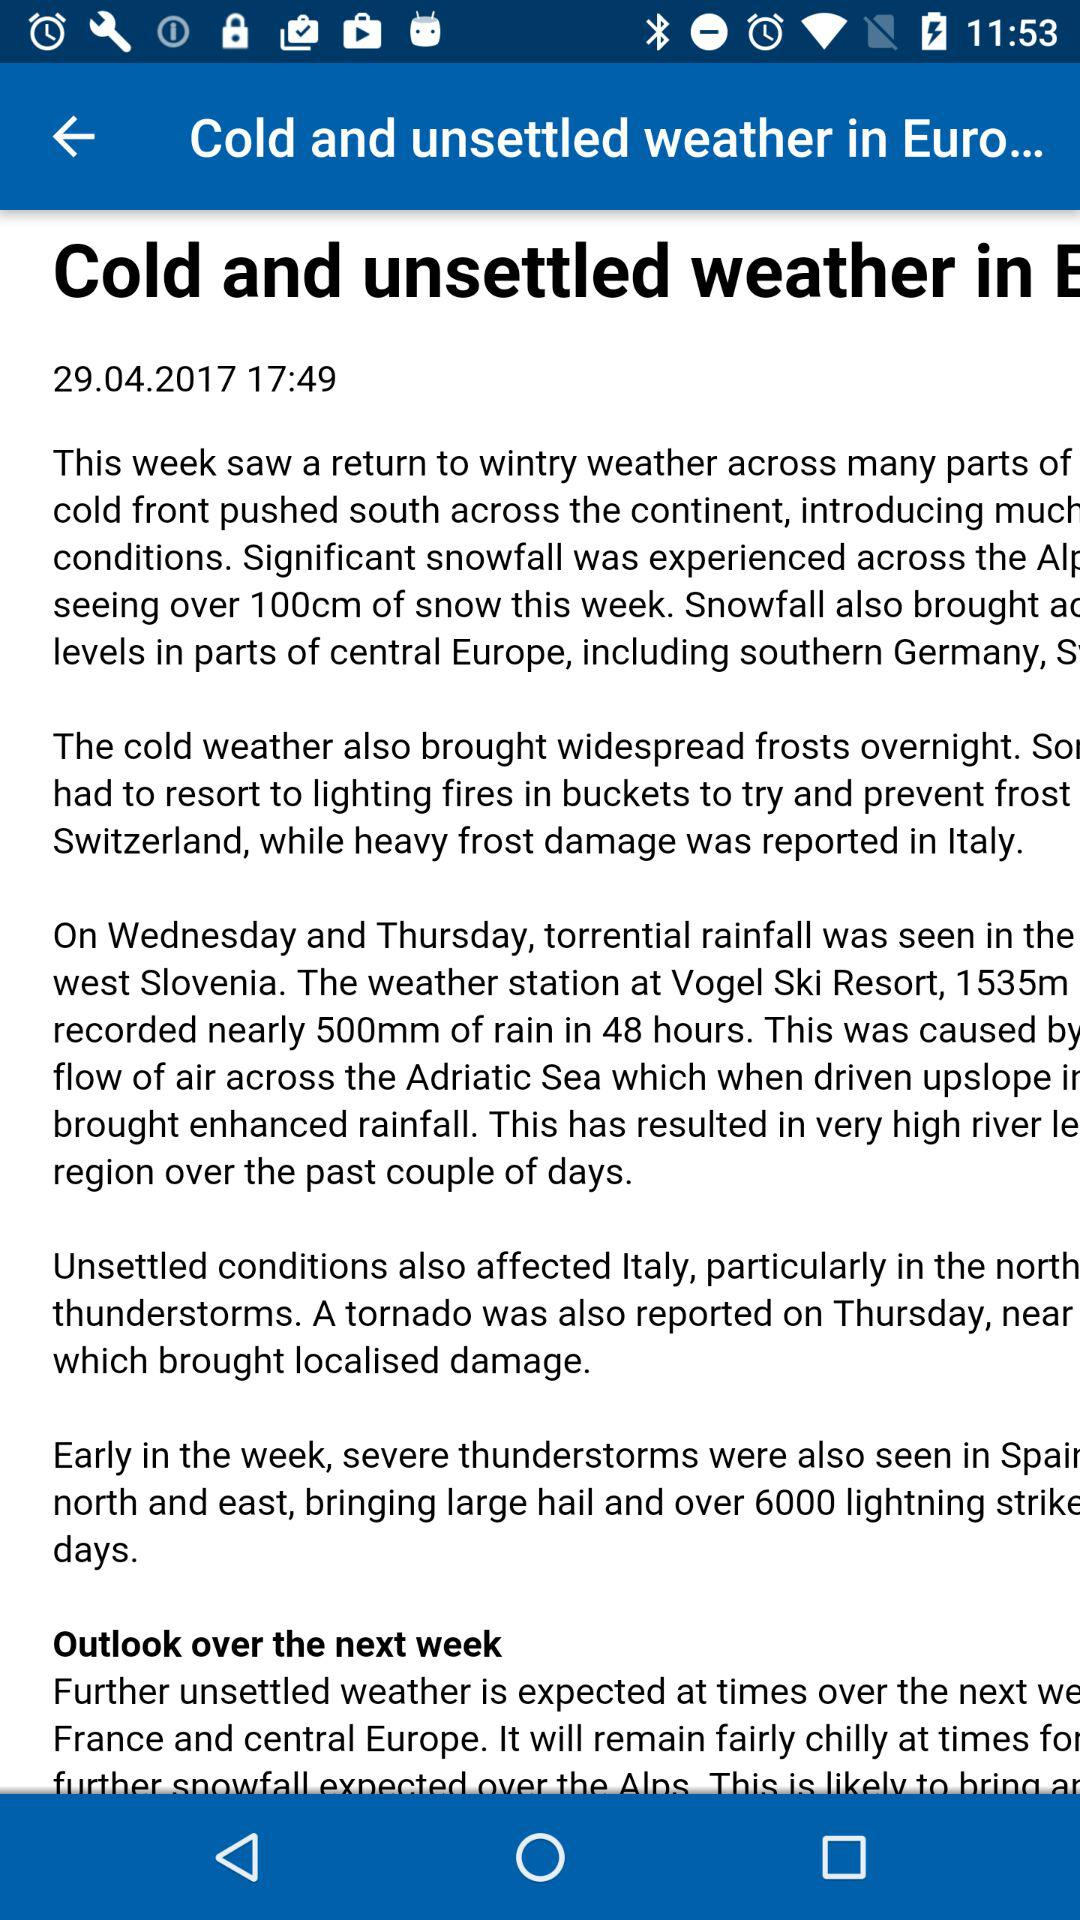What is the published date of the article? The date is April 29, 2017. 